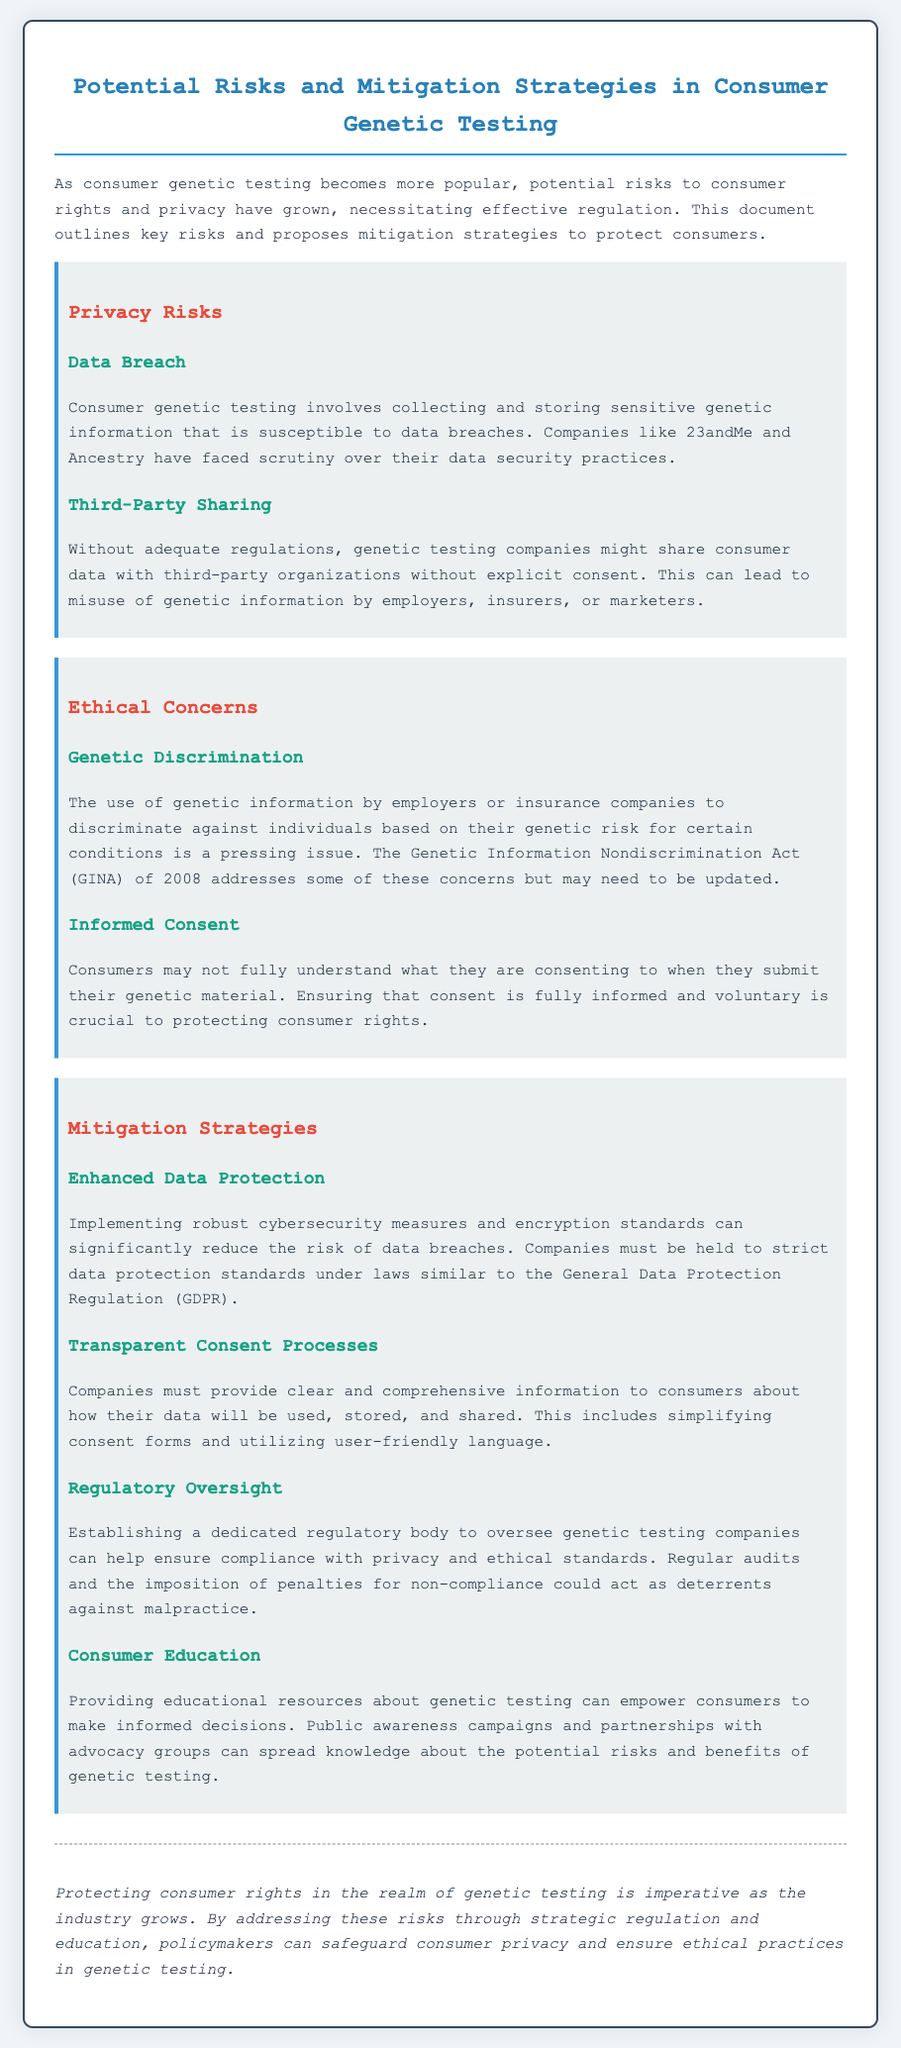what are the key risks associated with consumer genetic testing? Key risks mentioned in the document include privacy risks and ethical concerns.
Answer: privacy risks and ethical concerns who faced scrutiny over data security practices? The document states that companies like 23andMe and Ancestry have faced scrutiny.
Answer: 23andMe and Ancestry what act addresses genetic discrimination? The Genetic Information Nondiscrimination Act (GINA) of 2008 addresses genetic discrimination.
Answer: Genetic Information Nondiscrimination Act (GINA) what is a proposed mitigation strategy for data protection? A proposed mitigation strategy is implementing robust cybersecurity measures and encryption standards.
Answer: enhanced data protection how does the document suggest improving consumer consent processes? The document suggests providing clear and comprehensive information to consumers about data use and sharing.
Answer: transparent consent processes what is critical for protecting consumer rights according to the conclusion? Protecting consumer rights in the realm of genetic testing is critical.
Answer: protecting consumer rights what role is suggested for regulatory bodies in genetic testing? The document suggests establishing a dedicated regulatory body to oversee genetic testing companies.
Answer: regulatory oversight what educational approach is recommended for consumers? Providing educational resources about genetic testing is recommended.
Answer: consumer education 